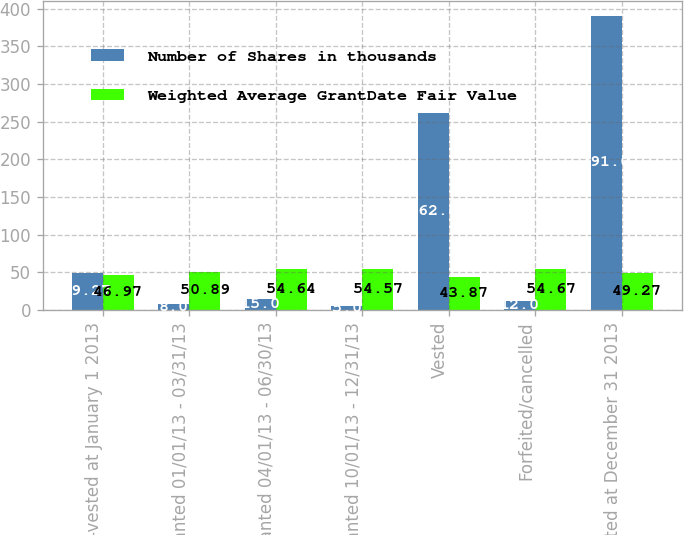<chart> <loc_0><loc_0><loc_500><loc_500><stacked_bar_chart><ecel><fcel>Non-vested at January 1 2013<fcel>Granted 01/01/13 - 03/31/13<fcel>Granted 04/01/13 - 06/30/13<fcel>Granted 10/01/13 - 12/31/13<fcel>Vested<fcel>Forfeited/cancelled<fcel>Non-vested at December 31 2013<nl><fcel>Number of Shares in thousands<fcel>49.27<fcel>8<fcel>15<fcel>5<fcel>262<fcel>12<fcel>391<nl><fcel>Weighted Average GrantDate Fair Value<fcel>46.97<fcel>50.89<fcel>54.64<fcel>54.57<fcel>43.87<fcel>54.67<fcel>49.27<nl></chart> 